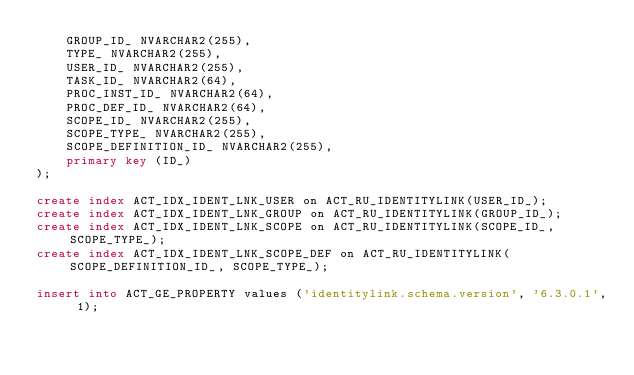Convert code to text. <code><loc_0><loc_0><loc_500><loc_500><_SQL_>    GROUP_ID_ NVARCHAR2(255),
    TYPE_ NVARCHAR2(255),
    USER_ID_ NVARCHAR2(255),
    TASK_ID_ NVARCHAR2(64),
    PROC_INST_ID_ NVARCHAR2(64),
    PROC_DEF_ID_ NVARCHAR2(64),
    SCOPE_ID_ NVARCHAR2(255),
    SCOPE_TYPE_ NVARCHAR2(255),
    SCOPE_DEFINITION_ID_ NVARCHAR2(255),
    primary key (ID_)
);

create index ACT_IDX_IDENT_LNK_USER on ACT_RU_IDENTITYLINK(USER_ID_);
create index ACT_IDX_IDENT_LNK_GROUP on ACT_RU_IDENTITYLINK(GROUP_ID_);
create index ACT_IDX_IDENT_LNK_SCOPE on ACT_RU_IDENTITYLINK(SCOPE_ID_, SCOPE_TYPE_);
create index ACT_IDX_IDENT_LNK_SCOPE_DEF on ACT_RU_IDENTITYLINK(SCOPE_DEFINITION_ID_, SCOPE_TYPE_);

insert into ACT_GE_PROPERTY values ('identitylink.schema.version', '6.3.0.1', 1);</code> 